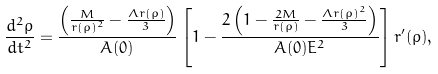<formula> <loc_0><loc_0><loc_500><loc_500>\frac { d ^ { 2 } \rho } { d t ^ { 2 } } = \frac { \left ( \frac { M } { r ( \rho ) ^ { 2 } } - \frac { \Lambda r ( \rho ) } { 3 } \right ) } { A ( 0 ) } \left [ 1 - \frac { 2 \left ( 1 - \frac { 2 M } { r ( \rho ) } - \frac { \Lambda r ( \rho ) ^ { 2 } } { 3 } \right ) } { A ( 0 ) E ^ { 2 } } \right ] r ^ { \prime } ( \rho ) ,</formula> 